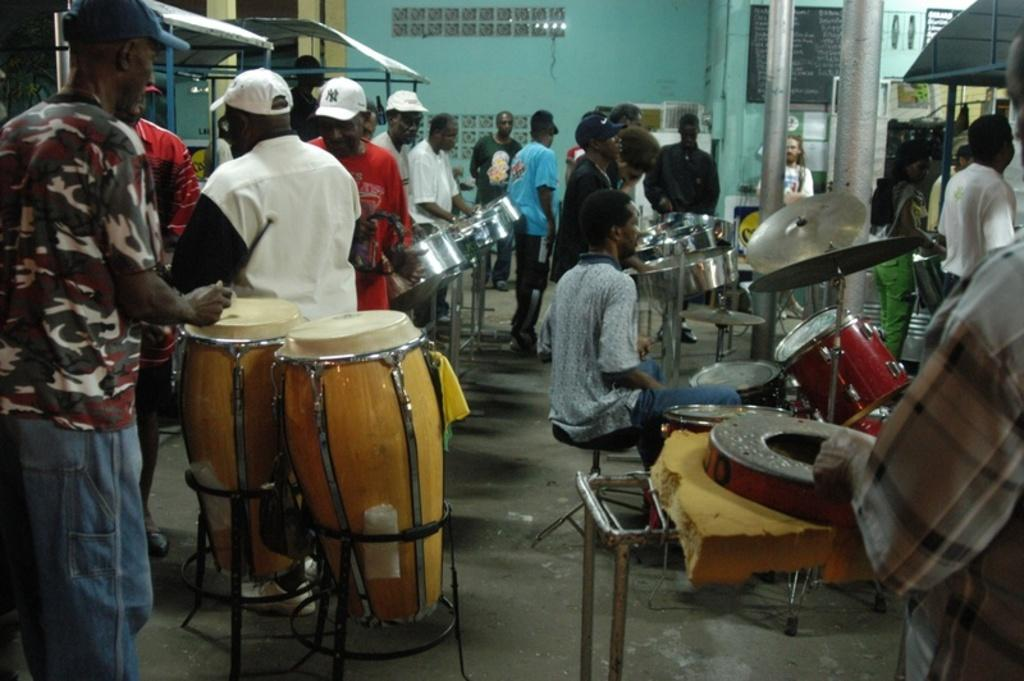How many people are in the image? There are many people standing in the image. What are the people holding in front of them? Most of the people have drums in front of them. Are there any accessories being worn by the people? Some people are wearing caps. What can be seen in the background of the image? There is a wall in the background of the image. What type of horn can be heard in the image? There is no horn present in the image, and therefore no sound can be heard. 